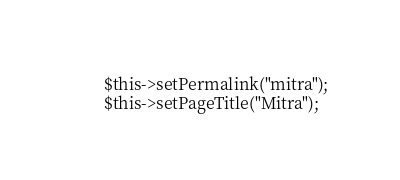<code> <loc_0><loc_0><loc_500><loc_500><_PHP_>        $this->setPermalink("mitra");
        $this->setPageTitle("Mitra");
</code> 